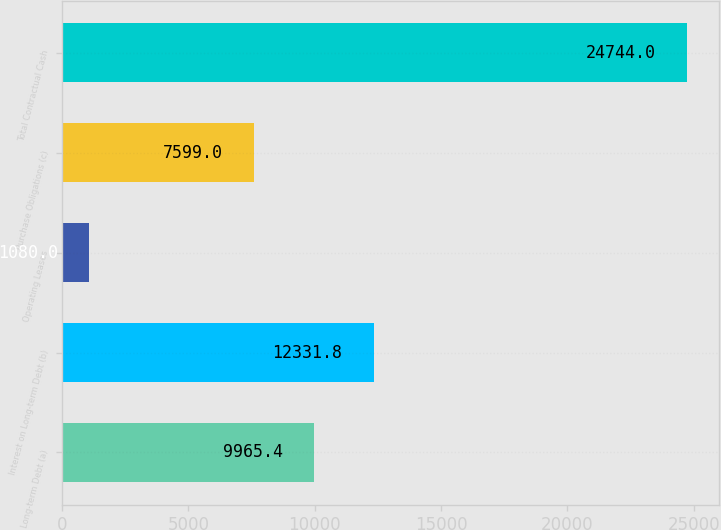Convert chart to OTSL. <chart><loc_0><loc_0><loc_500><loc_500><bar_chart><fcel>Long-term Debt (a)<fcel>Interest on Long-term Debt (b)<fcel>Operating Leases<fcel>Purchase Obligations (c)<fcel>Total Contractual Cash<nl><fcel>9965.4<fcel>12331.8<fcel>1080<fcel>7599<fcel>24744<nl></chart> 